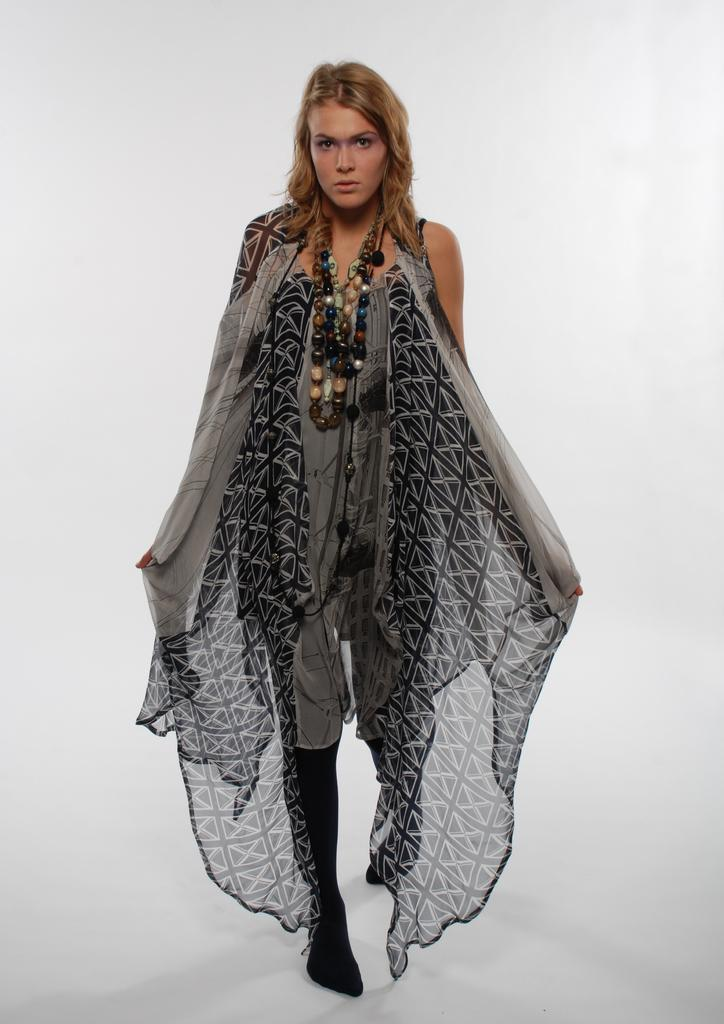Who is the main subject in the image? There is a woman in the image. Where is the woman positioned in the image? The woman is standing in the center of the image. What is the woman standing on in the image? The woman is standing on the floor. How many jars can be seen in the image? There are no jars present in the image. What type of change is the woman holding in the image? There is no change visible in the image, as the woman is not holding anything. 